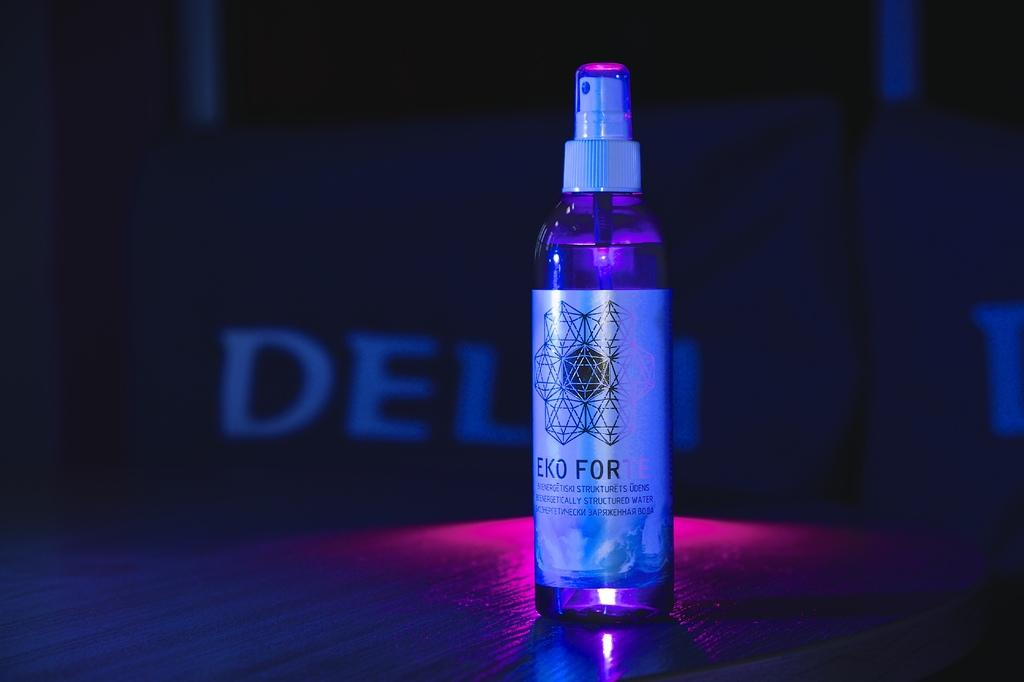What object can be seen in the image? There is a bottle in the image. What is unique about the bottle? The bottle has a label on it. What type of activity is the flesh of the brother engaged in within the image? There is no flesh or brother present in the image; it only features a bottle with a label on it. 